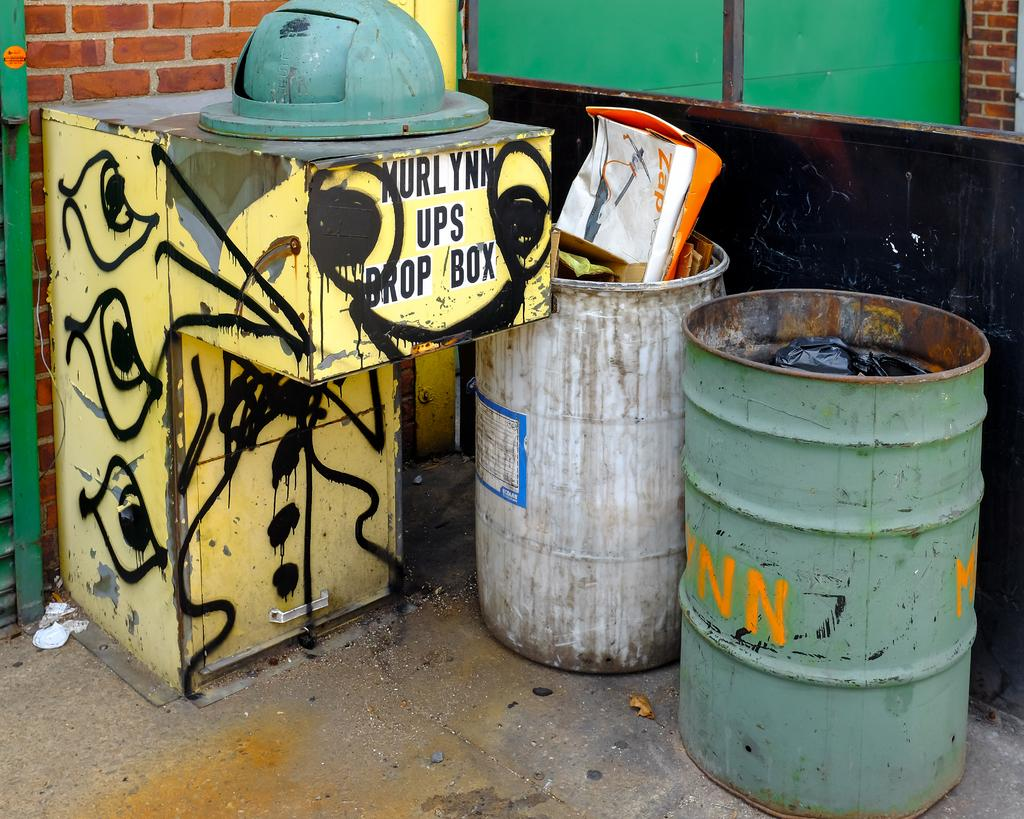<image>
Relay a brief, clear account of the picture shown. Trash bins sit beside a yellow bin with the words UPS Drop Box on the front. 